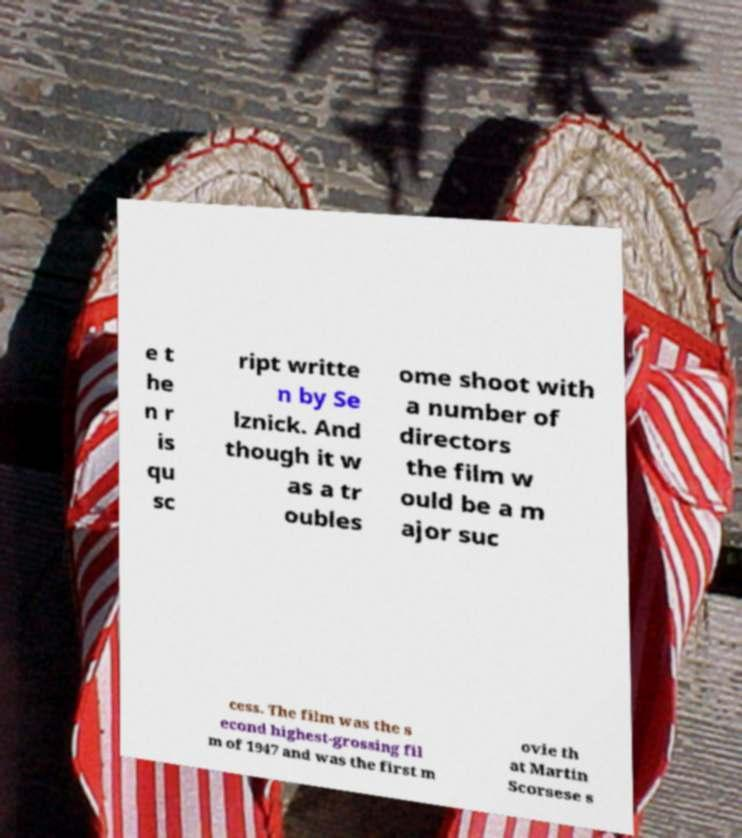Can you accurately transcribe the text from the provided image for me? e t he n r is qu sc ript writte n by Se lznick. And though it w as a tr oubles ome shoot with a number of directors the film w ould be a m ajor suc cess. The film was the s econd highest-grossing fil m of 1947 and was the first m ovie th at Martin Scorsese s 